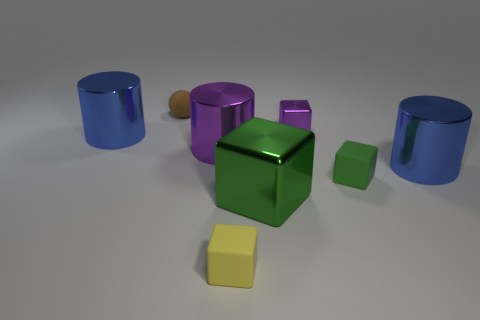Add 1 large green metal blocks. How many objects exist? 9 Subtract all cylinders. How many objects are left? 5 Subtract 1 blue cylinders. How many objects are left? 7 Subtract all large blue metal blocks. Subtract all big cubes. How many objects are left? 7 Add 5 brown objects. How many brown objects are left? 6 Add 5 tiny red rubber spheres. How many tiny red rubber spheres exist? 5 